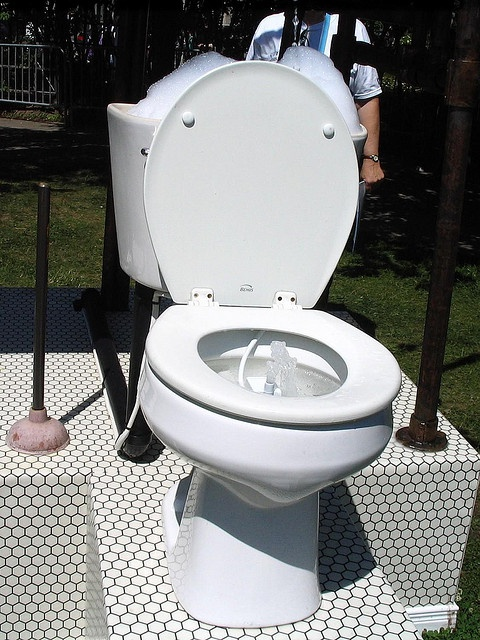Describe the objects in this image and their specific colors. I can see toilet in black, lightgray, gray, and darkgray tones and people in black, lavender, and gray tones in this image. 